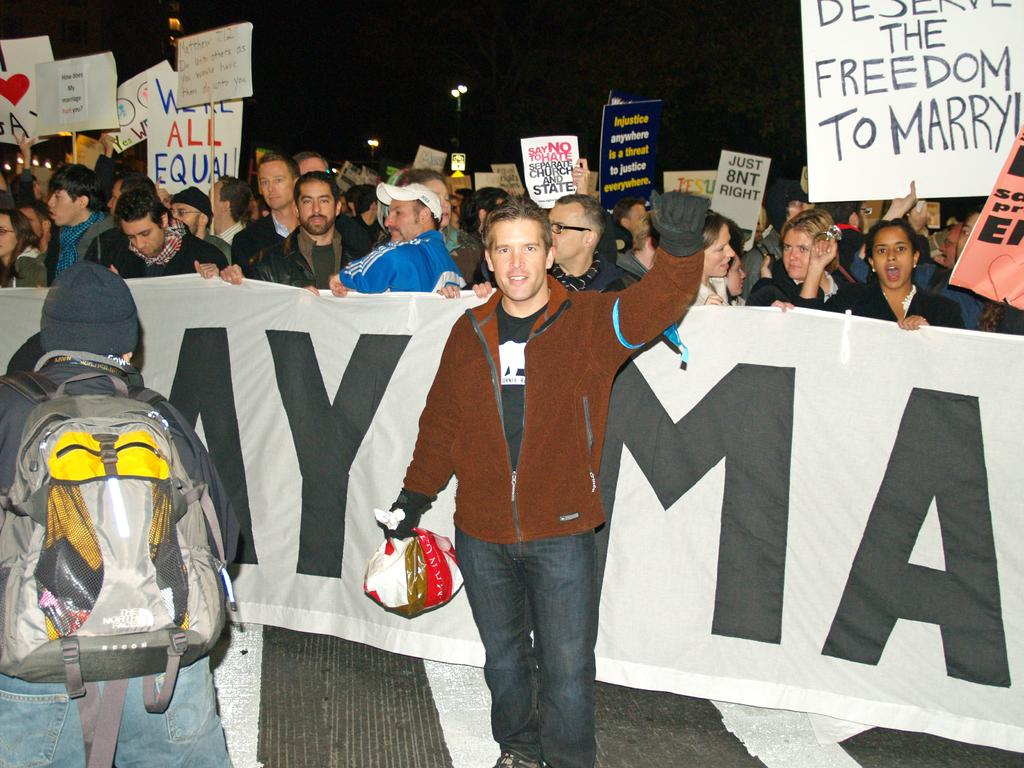Who or what is present in the image? There are people in the image. What are the people doing in the image? The people are standing on the floor and holding papers. What can be seen in the background of the image? The background of the image is dark. What type of punishment is being administered to the people in the image? There is no indication of punishment in the image; the people are simply standing and holding papers. 